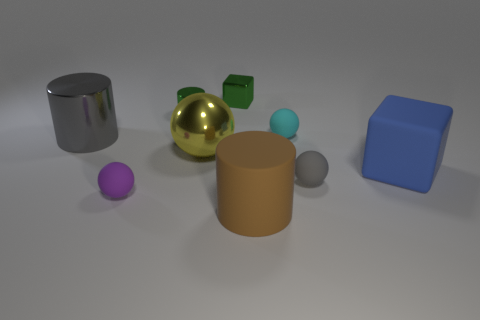Are any green objects visible?
Offer a terse response. Yes. What size is the thing that is both in front of the yellow sphere and left of the yellow metallic ball?
Your answer should be very brief. Small. Are there more large gray metallic cylinders to the right of the tiny purple matte sphere than gray matte things that are behind the tiny green cylinder?
Your answer should be compact. No. There is a metallic cube that is the same color as the small metallic cylinder; what size is it?
Provide a short and direct response. Small. The shiny block is what color?
Make the answer very short. Green. The small thing that is to the left of the brown rubber thing and in front of the gray metallic cylinder is what color?
Offer a terse response. Purple. There is a metal cylinder that is right of the gray metal cylinder that is to the left of the big rubber thing in front of the big blue rubber thing; what is its color?
Offer a terse response. Green. The metal cylinder that is the same size as the purple rubber object is what color?
Ensure brevity in your answer.  Green. What is the shape of the green thing that is to the left of the cube that is left of the big cylinder right of the big shiny cylinder?
Keep it short and to the point. Cylinder. There is a metallic object that is the same color as the tiny metallic cube; what is its shape?
Ensure brevity in your answer.  Cylinder. 